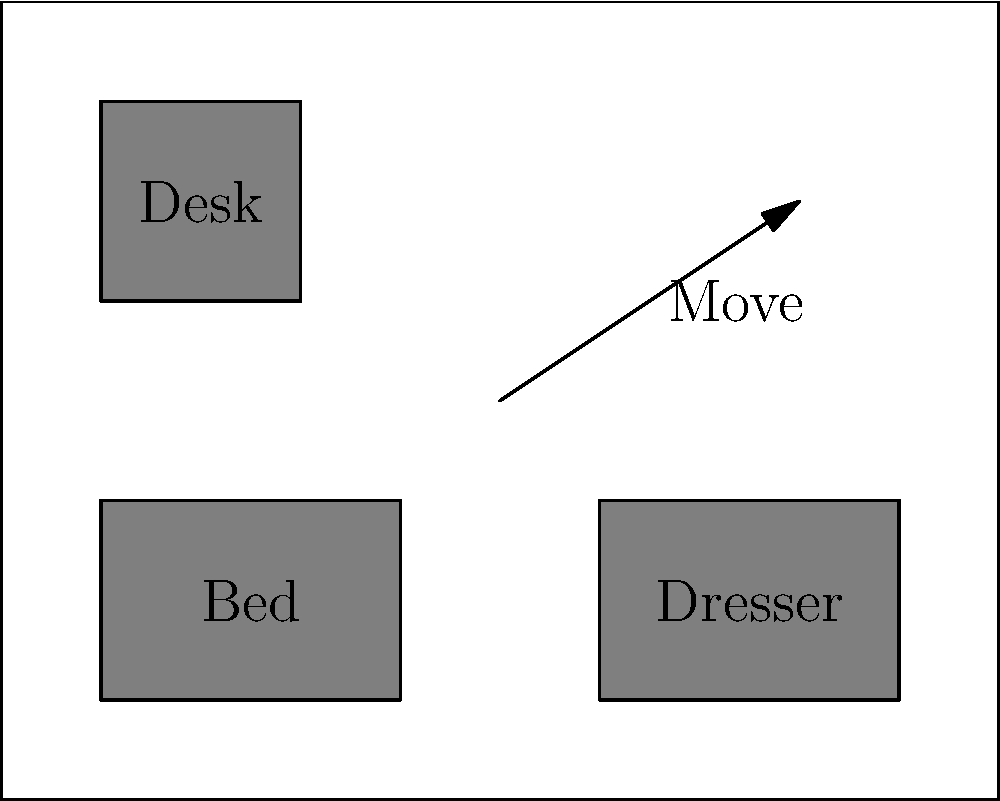Your friend, a former plant employee, needs to set up a home office in their bedroom. The current layout includes a bed, dresser, and desk. To create more space for office equipment, which piece of furniture should be moved, and where should it be relocated to maximize the available working area? To solve this spatial reasoning task, let's follow these steps:

1. Analyze the current layout:
   - The bed and dresser are placed along the bottom wall.
   - The desk is in the top-left corner.

2. Identify the goal:
   - Create more space for office equipment.
   - Maximize the available working area.

3. Consider the furniture pieces:
   - The bed is essential and typically requires the most space.
   - The dresser is large but can be more flexibly placed.
   - The desk is already in a corner, which is often an efficient use of space.

4. Evaluate potential moves:
   - Moving the bed would be impractical and wouldn't create much additional space.
   - Moving the desk to another corner wouldn't significantly increase the working area.
   - Moving the dresser to the top-right corner would create a large, open area in the center of the room.

5. Determine the best solution:
   - Relocating the dresser to the top-right corner would:
     a) Create a spacious L-shaped working area.
     b) Allow for the addition of office equipment without obstructing movement.
     c) Maintain easy access to all furniture pieces.

Therefore, the optimal solution is to move the dresser to the top-right corner of the room, creating a larger continuous space for the home office setup.
Answer: Move dresser to top-right corner 